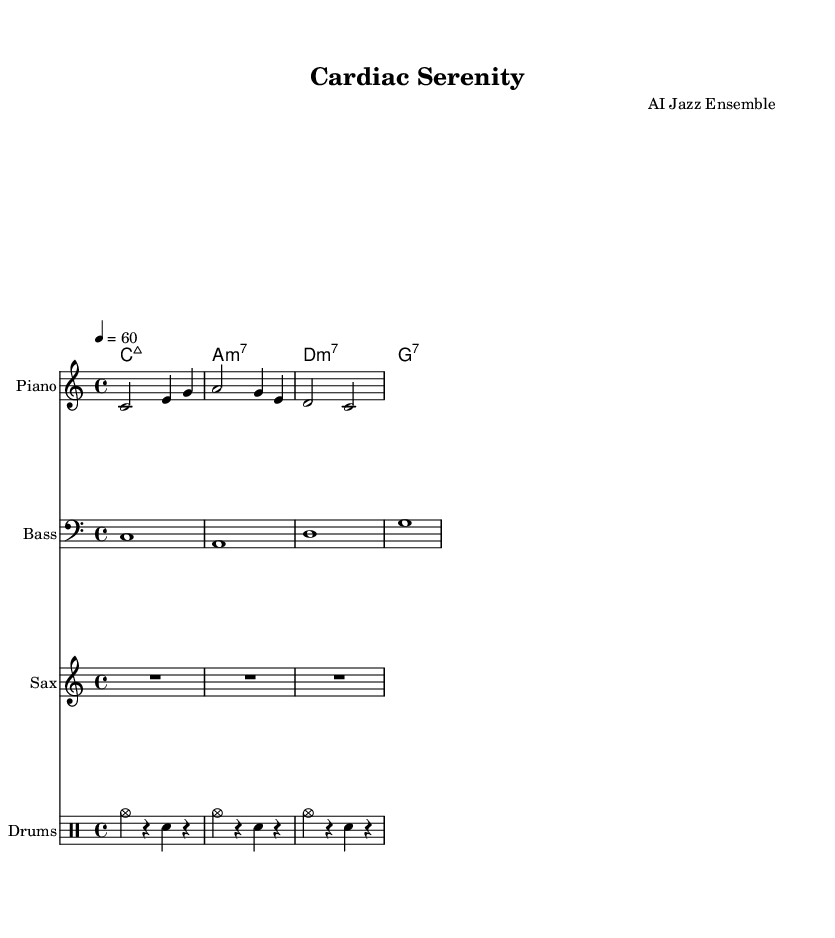What is the key signature of this music? The music is in C major, which features no sharps or flats. This is evident from the key signature indicated at the beginning of the score.
Answer: C major What is the time signature of this piece? The time signature is 4/4, which is the most common time signature in music. This means there are 4 beats in each measure and the quarter note gets one beat. This can be seen right at the start of the score.
Answer: 4/4 What is the tempo marking for this piece? The tempo marking is 60 beats per minute, indicated by the tempo notation "4 = 60". This means there are 60 quarter note beats in one minute. This can be found in the global settings at the beginning of the code.
Answer: 60 Which instruments are included in the score? The score includes Piano, Bass, Saxophone, and Drums. Each instrument is represented in its own staff, labeled accordingly. This can be seen in the layout section of the score where each instrument is mentioned.
Answer: Piano, Bass, Saxophone, Drums How many measures are in the piano part? The piano part contains three measures, as indicated by the structure of the notes in the piano section of the score. Each group of notes separated by the vertical bar represents one measure.
Answer: 3 What type of chord is played in the first measure of the chord progression? The chord in the first measure is a major 7th chord (Cmaj7). This can be determined by looking at the chord symbols above the staff; "c1:maj7" indicates that a C major 7th chord is played in that measure.
Answer: Major 7th What style of jazz is reflected in the arrangement? The arrangement reflects a contemporary jazz style, characterized by its soothing melodies and simple harmonic structure. The combination of instrumental voices creates a relaxing atmosphere typical of contemporary jazz.
Answer: Contemporary jazz 